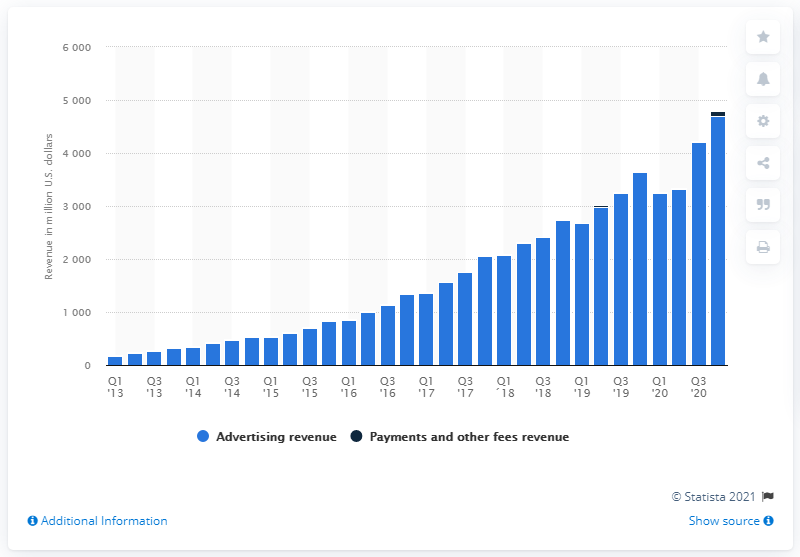Draw attention to some important aspects in this diagram. Facebook's advertising revenue in the Asia Pacific region for the fourth quarter of 2020 was $4703 million. In the first quarter of 2013, Facebook's advertising revenue in the Asia Pacific region was $176 million. 